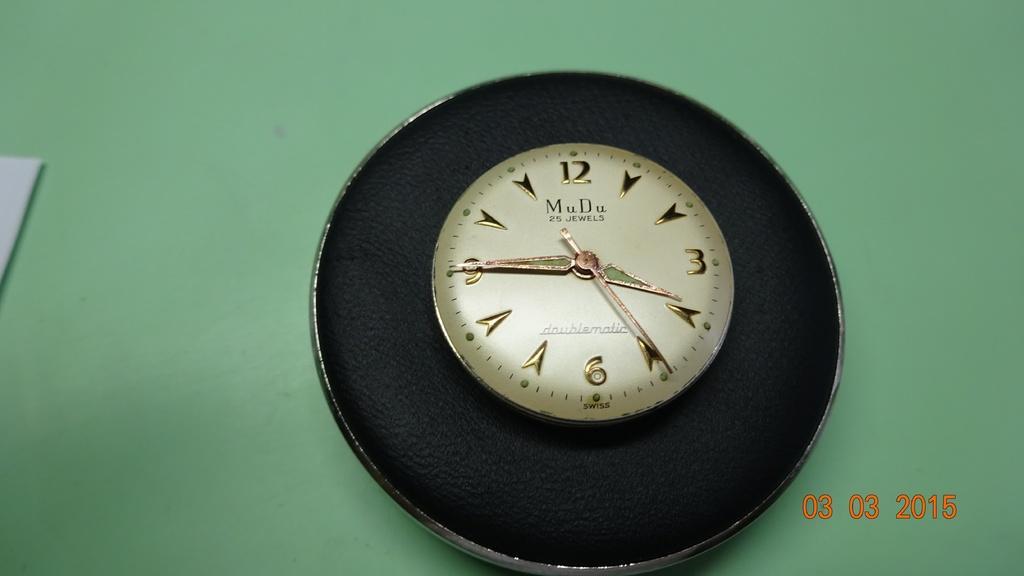Can you describe this image briefly? In the image there is a wall clock on the green wall. 